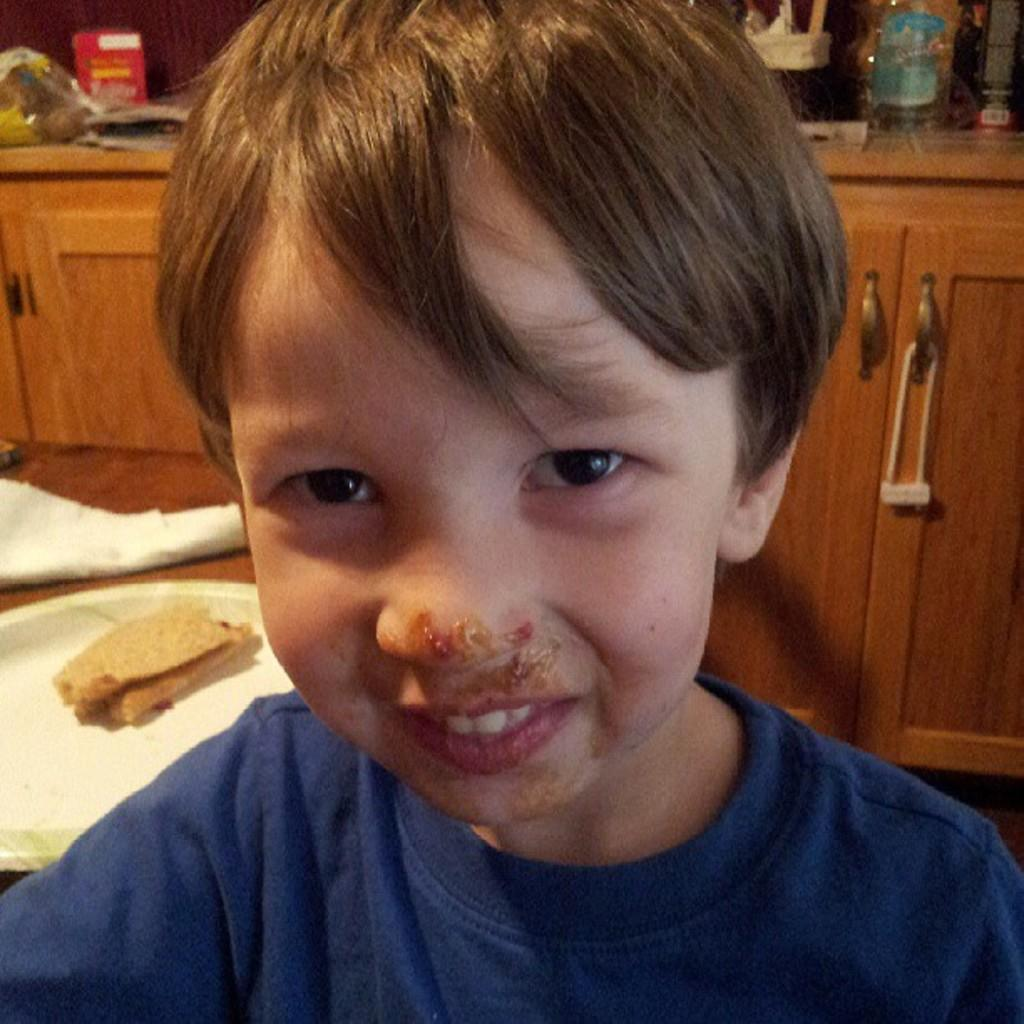Who is the main subject in the image? There is a boy in the image. What is the boy wearing? The boy is wearing a blue T-shirt. What can be seen in the background of the image? There is a plate with food items and wooden cupboards in the background. Are there any other objects visible in the background? Yes, there are other objects visible in the background. Can you tell me how many plants are in the boy's plantation in the image? There is no plantation present in the image, as it features a boy wearing a blue T-shirt with a background that includes a plate with food items and wooden cupboards. Is there a flock of birds visible in the image? There is no flock of birds present in the image. 